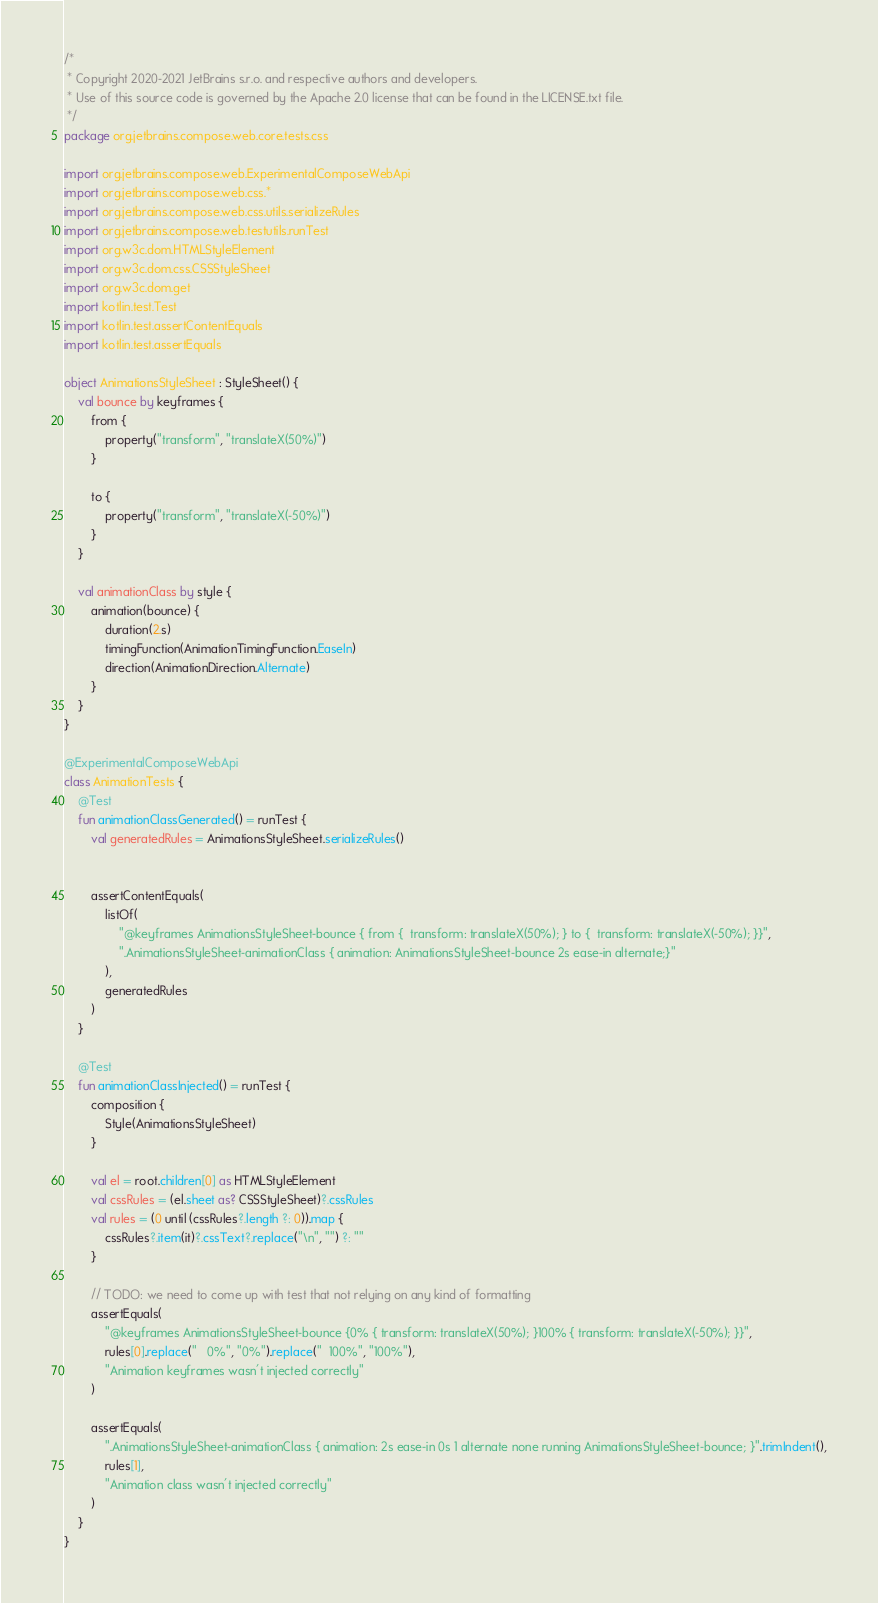Convert code to text. <code><loc_0><loc_0><loc_500><loc_500><_Kotlin_>/*
 * Copyright 2020-2021 JetBrains s.r.o. and respective authors and developers.
 * Use of this source code is governed by the Apache 2.0 license that can be found in the LICENSE.txt file.
 */
package org.jetbrains.compose.web.core.tests.css

import org.jetbrains.compose.web.ExperimentalComposeWebApi
import org.jetbrains.compose.web.css.*
import org.jetbrains.compose.web.css.utils.serializeRules
import org.jetbrains.compose.web.testutils.runTest
import org.w3c.dom.HTMLStyleElement
import org.w3c.dom.css.CSSStyleSheet
import org.w3c.dom.get
import kotlin.test.Test
import kotlin.test.assertContentEquals
import kotlin.test.assertEquals

object AnimationsStyleSheet : StyleSheet() {
    val bounce by keyframes {
        from {
            property("transform", "translateX(50%)")
        }

        to {
            property("transform", "translateX(-50%)")
        }
    }

    val animationClass by style {
        animation(bounce) {
            duration(2.s)
            timingFunction(AnimationTimingFunction.EaseIn)
            direction(AnimationDirection.Alternate)
        }
    }
}

@ExperimentalComposeWebApi
class AnimationTests {
    @Test
    fun animationClassGenerated() = runTest {
        val generatedRules = AnimationsStyleSheet.serializeRules()


        assertContentEquals(
            listOf(
                "@keyframes AnimationsStyleSheet-bounce { from {  transform: translateX(50%); } to {  transform: translateX(-50%); }}",
                ".AnimationsStyleSheet-animationClass { animation: AnimationsStyleSheet-bounce 2s ease-in alternate;}"
            ),
            generatedRules
        )
    }

    @Test
    fun animationClassInjected() = runTest {
        composition {
            Style(AnimationsStyleSheet)
        }

        val el = root.children[0] as HTMLStyleElement
        val cssRules = (el.sheet as? CSSStyleSheet)?.cssRules
        val rules = (0 until (cssRules?.length ?: 0)).map {
            cssRules?.item(it)?.cssText?.replace("\n", "") ?: ""
        }

        // TODO: we need to come up with test that not relying on any kind of formatting
        assertEquals(
            "@keyframes AnimationsStyleSheet-bounce {0% { transform: translateX(50%); }100% { transform: translateX(-50%); }}",
            rules[0].replace("   0%", "0%").replace("  100%", "100%"),
            "Animation keyframes wasn't injected correctly"
        )

        assertEquals(
            ".AnimationsStyleSheet-animationClass { animation: 2s ease-in 0s 1 alternate none running AnimationsStyleSheet-bounce; }".trimIndent(),
            rules[1],
            "Animation class wasn't injected correctly"
        )
    }
}
</code> 